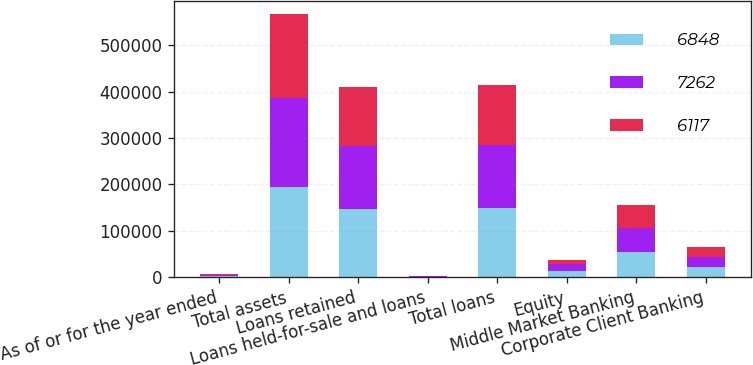Convert chart. <chart><loc_0><loc_0><loc_500><loc_500><stacked_bar_chart><ecel><fcel>As of or for the year ended<fcel>Total assets<fcel>Loans retained<fcel>Loans held-for-sale and loans<fcel>Total loans<fcel>Equity<fcel>Middle Market Banking<fcel>Corporate Client Banking<nl><fcel>6848<fcel>2014<fcel>195267<fcel>147661<fcel>845<fcel>148506<fcel>14000<fcel>53635<fcel>22695<nl><fcel>7262<fcel>2013<fcel>190782<fcel>135750<fcel>1388<fcel>137138<fcel>13500<fcel>52289<fcel>20925<nl><fcel>6117<fcel>2012<fcel>181502<fcel>126996<fcel>1212<fcel>128208<fcel>9500<fcel>50552<fcel>21707<nl></chart> 